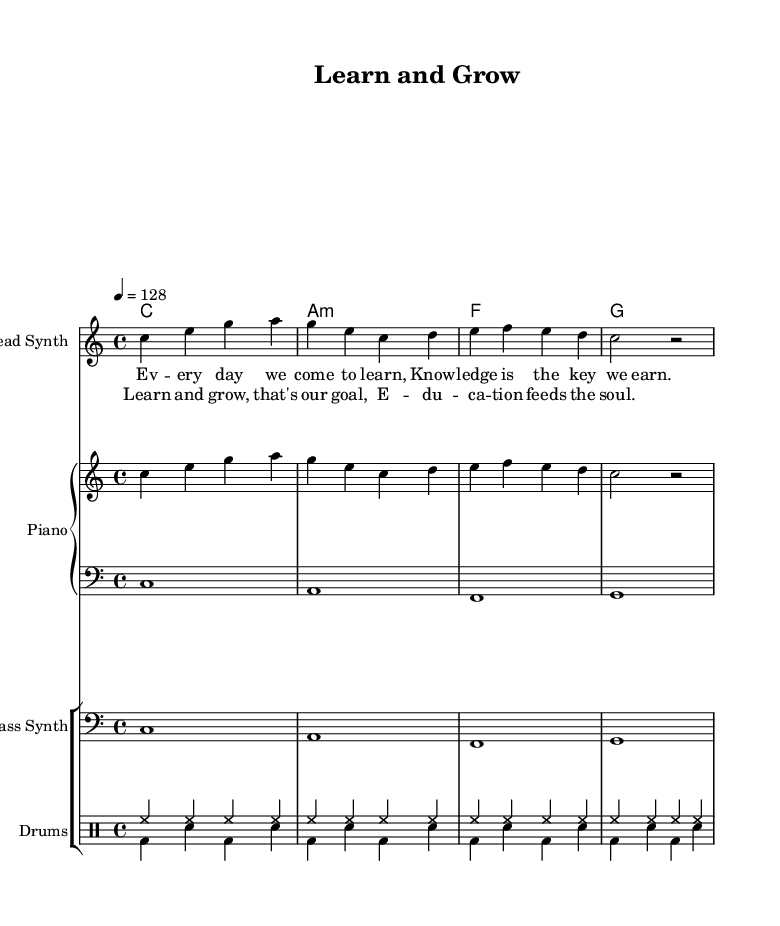What is the key signature of this music? The key signature is indicated at the beginning of the score and it is C major, which is represented by no sharps or flats.
Answer: C major What is the time signature of this music? The time signature is located near the beginning of the sheet music, showing the division of beats per measure, which is 4/4 in this case.
Answer: 4/4 What is the tempo marking of this composition? The tempo marking is specified in beats per minute and it is set to 128 beats per minute, indicating the speed of the music.
Answer: 128 How many measures are there in the melody section? By counting the number of phrases or lines in the melody section, we find there are 4 measures represented.
Answer: 4 What is the primary theme of the lyrics? The lyrics suggest an educational theme, focusing on learning and the importance of knowledge as a goal for the students represented in the assembly.
Answer: Education What is the instrumentation used in the score? The instrumentation can be determined by looking at the labels in each staff; it includes "Lead Synth," "Piano," "Bass Synth," and "Drums."
Answer: Lead Synth, Piano, Bass Synth, Drums What musical genres influence the style of this piece? The characteristics of the piece, such as the strong beat and rhythmic style in the drums, as well as the melodic synth, indicate it draws from Electronic and EDM genres.
Answer: Electronic, EDM 